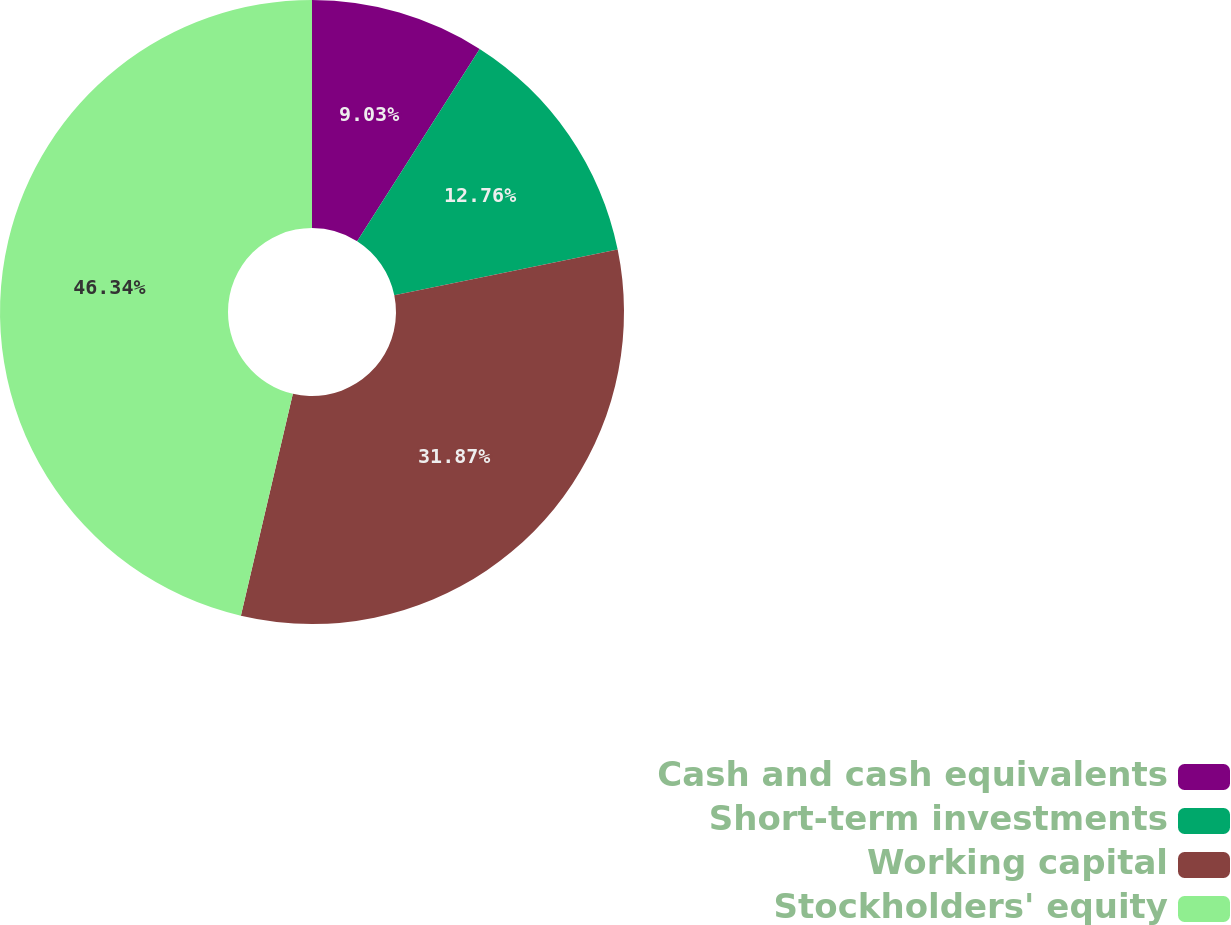Convert chart. <chart><loc_0><loc_0><loc_500><loc_500><pie_chart><fcel>Cash and cash equivalents<fcel>Short-term investments<fcel>Working capital<fcel>Stockholders' equity<nl><fcel>9.03%<fcel>12.76%<fcel>31.87%<fcel>46.34%<nl></chart> 